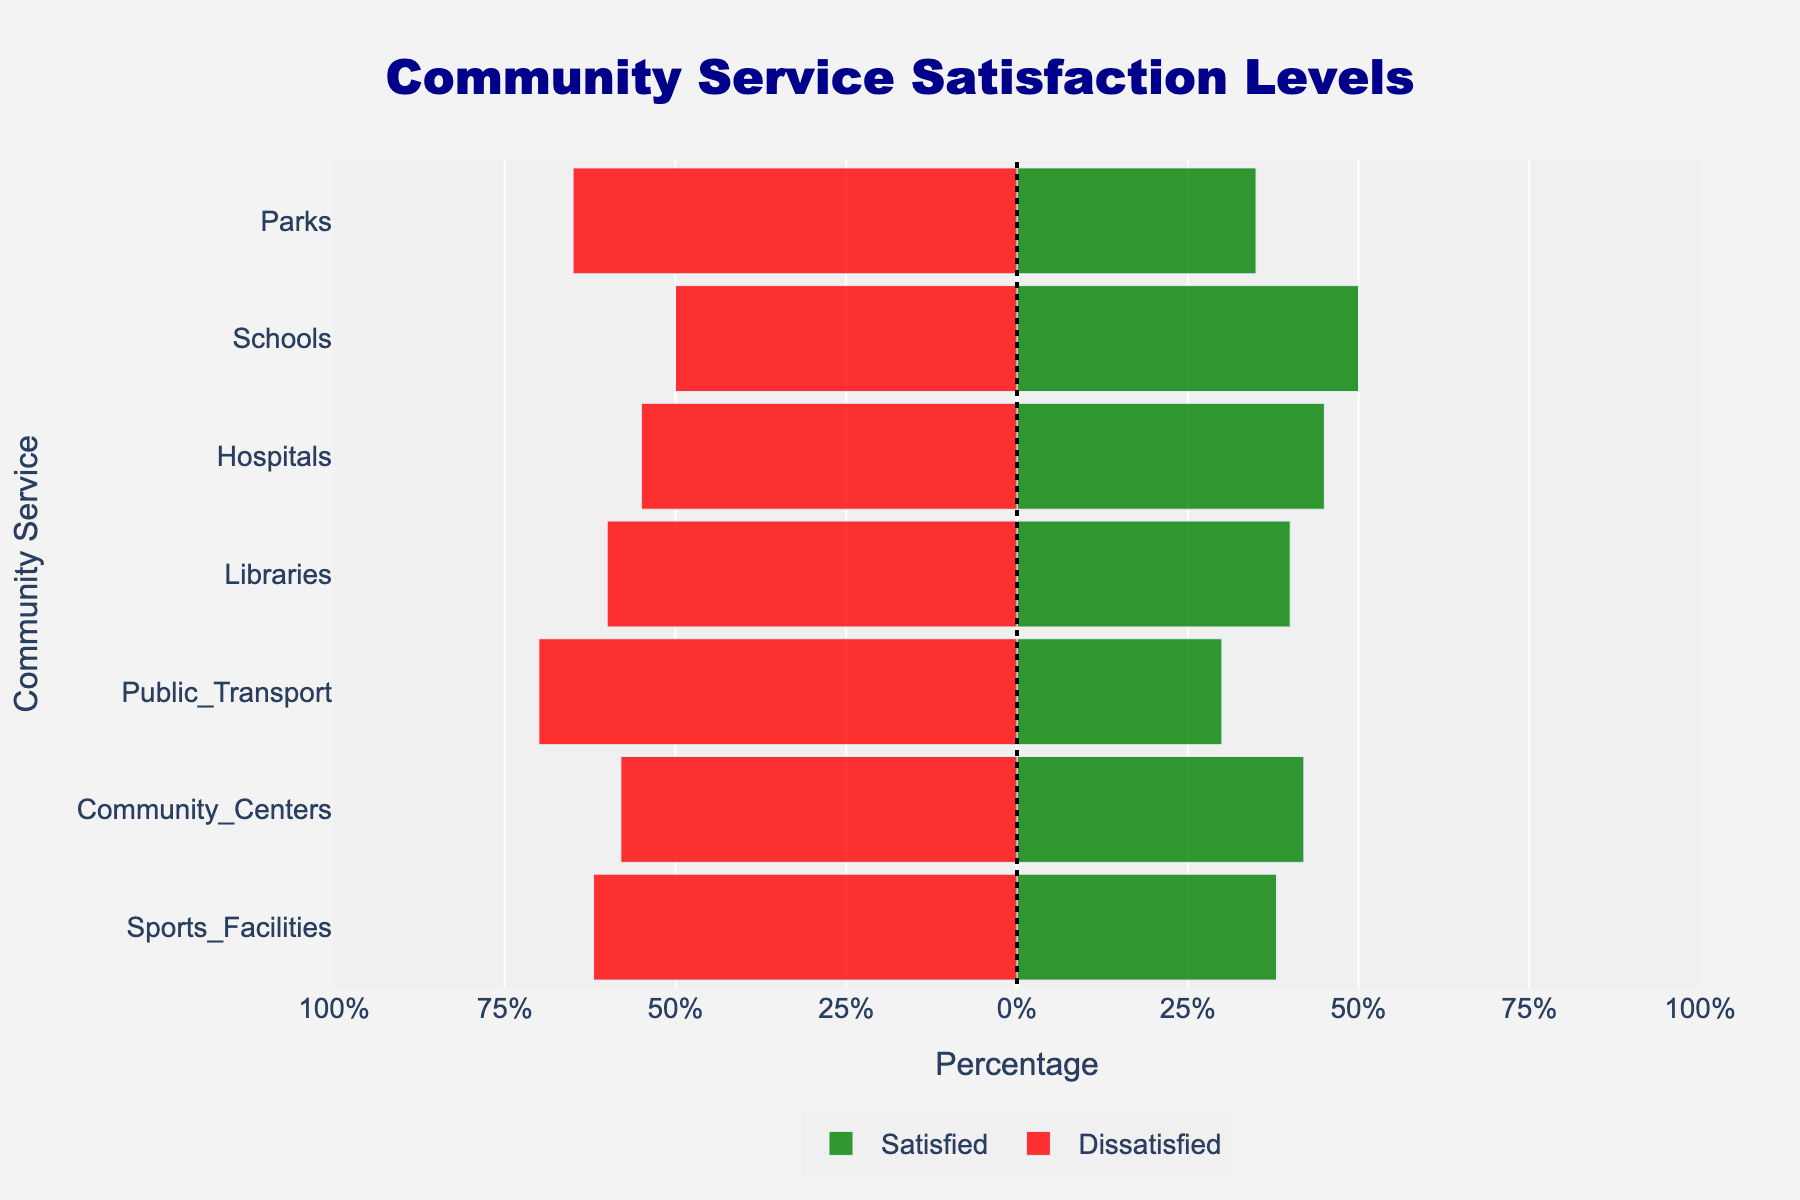What community service has the highest percentage of dissatisfied respondents? The bar for Public Transport is the longest in the negative direction, indicating it has the highest percentage of dissatisfied respondents.
Answer: Public Transport Which community service shows equal satisfaction and dissatisfaction among parents? The bar for Schools is centered on the vertical line, indicating that the percentage satisfied and percentage dissatisfied are the same.
Answer: Schools By how much do dissatisfaction and satisfaction percentages differ for Parks? The positive bar for Parks is at 35%, and the negative bar is at -65%. The difference is 65% - 35% = 30%.
Answer: 30% Which community service has the lowest percentage of satisfied respondents? The bar for Public Transport in the positive direction is the shortest, indicating it has the lowest percentage of satisfied respondents.
Answer: Public Transport Are parents more satisfied or dissatisfied with Hospitals? The negative bar for Hospitals is longer than the positive bar, indicating that parents are more dissatisfied than satisfied with Hospitals.
Answer: Dissatisfied Rank the community services from highest to lowest based on the percentage of satisfied respondents. From the positive bar lengths: Schools (50%), Hospitals (45%), Community Centers (42%), Libraries (40%), Sports Facilities (38%), Parks (35%), Public Transport (30%).
Answer: Schools > Hospitals > Community Centers > Libraries > Sports Facilities > Parks > Public Transport What is the average percentage of dissatisfaction across all community services? Add all dissatisfaction percentages: 65% + 50% + 55% + 60% + 70% + 58% + 62% = 420%, then divide by 7 (the number of services): 420% / 7 = 60%.
Answer: 60% Which community services have a higher percentage of satisfied respondents than dissatisfied respondents? Only the data for Schools where the positive bar (50%) is longer than or equal to the negative bar (50%) meets this criterion.
Answer: Schools By how much do satisfied respondents for Sports Facilities differ from Libraries? The positive bar for Sports Facilities is 38%, and for Libraries, it is 40%. The difference is 40% - 38% = 2%.
Answer: 2% Which community service has the largest gap between satisfaction and dissatisfaction percentages? Public Transport has the bars showing the widest gap: positive bar at 30% and negative bar at -70%, giving a gap of 70% - 30% = 40%.
Answer: Public Transport 